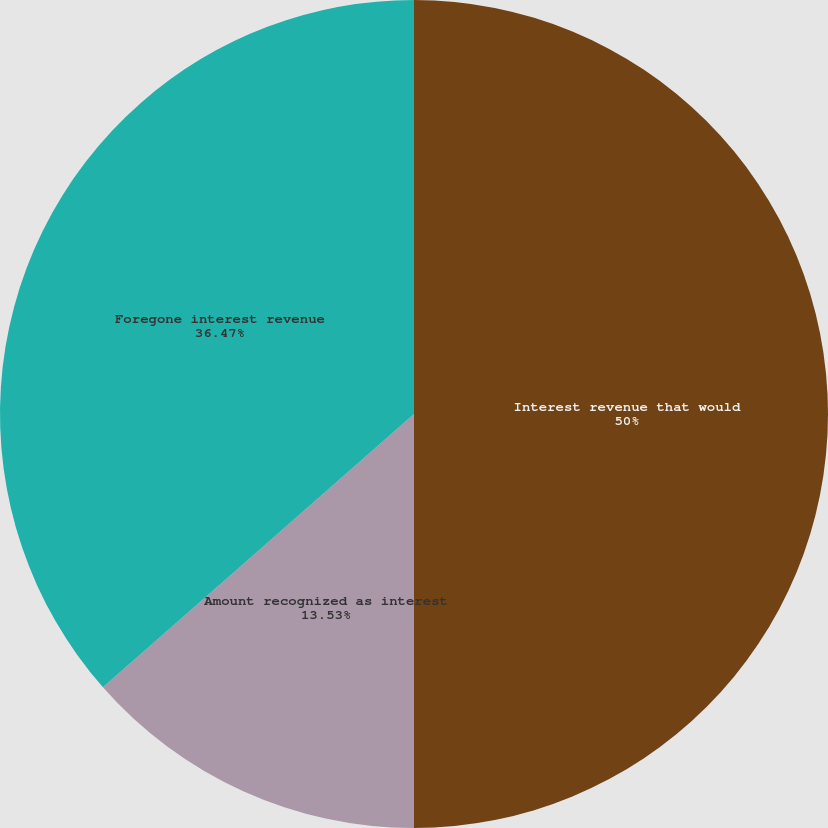<chart> <loc_0><loc_0><loc_500><loc_500><pie_chart><fcel>Interest revenue that would<fcel>Amount recognized as interest<fcel>Foregone interest revenue<nl><fcel>50.0%<fcel>13.53%<fcel>36.47%<nl></chart> 